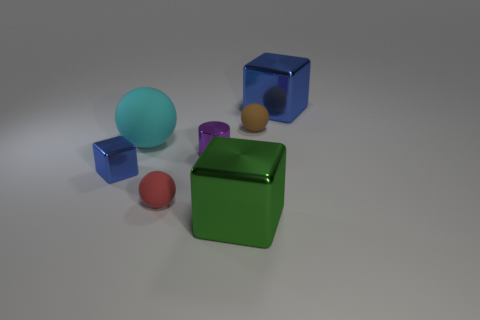Subtract all blue cylinders. How many blue blocks are left? 2 Add 2 purple shiny cylinders. How many objects exist? 9 Subtract all tiny matte balls. How many balls are left? 1 Subtract 1 spheres. How many spheres are left? 2 Subtract all yellow blocks. Subtract all brown cylinders. How many blocks are left? 3 Subtract all cylinders. How many objects are left? 6 Subtract 0 green spheres. How many objects are left? 7 Subtract all blue objects. Subtract all red rubber things. How many objects are left? 4 Add 5 small blue shiny cubes. How many small blue shiny cubes are left? 6 Add 5 green metal things. How many green metal things exist? 6 